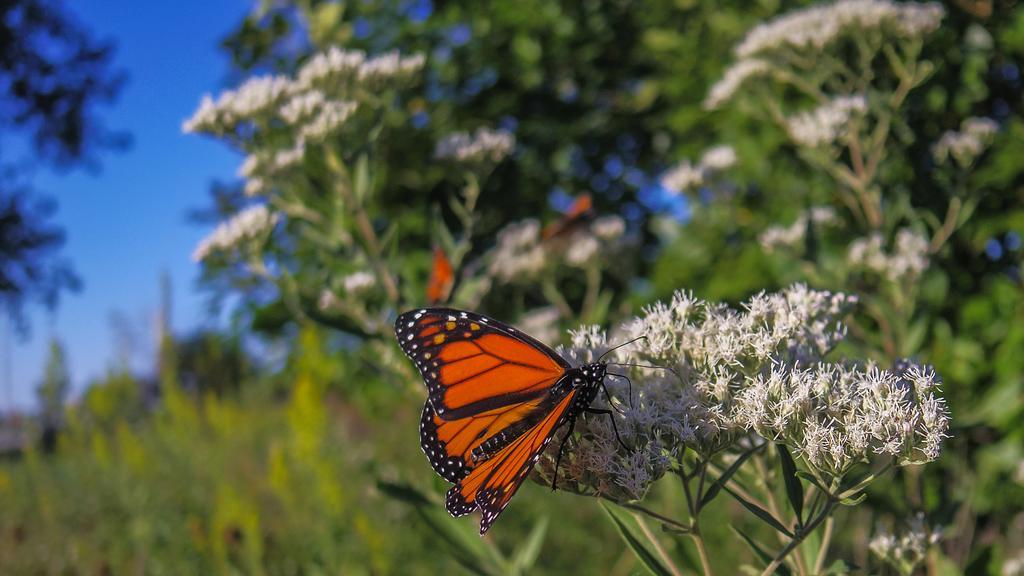Describe this image in one or two sentences. In this image in front there is a butterfly on flowers. In the background of the image there are trees and sky. 